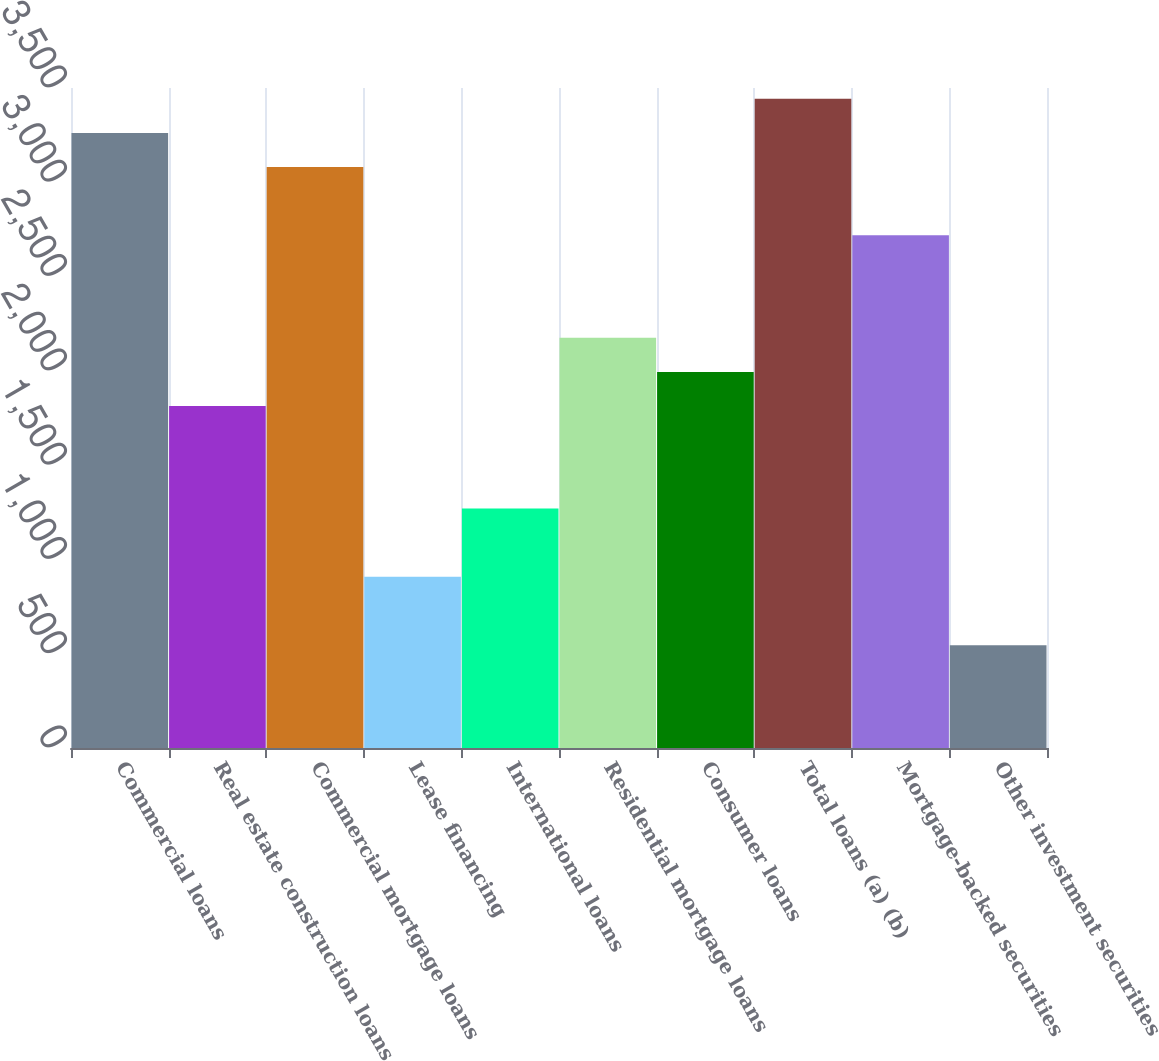Convert chart. <chart><loc_0><loc_0><loc_500><loc_500><bar_chart><fcel>Commercial loans<fcel>Real estate construction loans<fcel>Commercial mortgage loans<fcel>Lease financing<fcel>International loans<fcel>Residential mortgage loans<fcel>Consumer loans<fcel>Total loans (a) (b)<fcel>Mortgage-backed securities<fcel>Other investment securities<nl><fcel>3261.8<fcel>1813<fcel>3080.7<fcel>907.5<fcel>1269.7<fcel>2175.2<fcel>1994.1<fcel>3442.9<fcel>2718.5<fcel>545.3<nl></chart> 